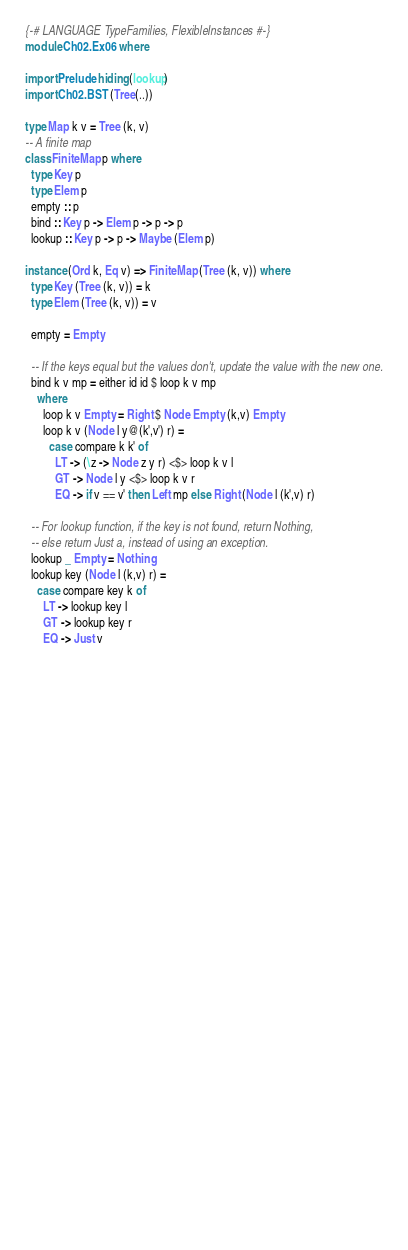<code> <loc_0><loc_0><loc_500><loc_500><_Haskell_>{-# LANGUAGE TypeFamilies, FlexibleInstances #-}
module Ch02.Ex06 where

import Prelude hiding (lookup)
import Ch02.BST (Tree(..))

type Map k v = Tree (k, v)
-- A finite map
class FiniteMap p where
  type Key p
  type Elem p
  empty :: p
  bind :: Key p -> Elem p -> p -> p
  lookup :: Key p -> p -> Maybe (Elem p)
  
instance (Ord k, Eq v) => FiniteMap (Tree (k, v)) where
  type Key (Tree (k, v)) = k
  type Elem (Tree (k, v)) = v
  
  empty = Empty
  
  -- If the keys equal but the values don't, update the value with the new one.
  bind k v mp = either id id $ loop k v mp 
    where
      loop k v Empty = Right $ Node Empty (k,v) Empty 
      loop k v (Node l y@(k',v') r) = 
        case compare k k' of
          LT -> (\z -> Node z y r) <$> loop k v l 
          GT -> Node l y <$> loop k v r
          EQ -> if v == v' then Left mp else Right (Node l (k',v) r)
  
  -- For lookup function, if the key is not found, return Nothing,
  -- else return Just a, instead of using an exception.
  lookup _ Empty = Nothing
  lookup key (Node l (k,v) r) = 
    case compare key k of 
      LT -> lookup key l 
      GT -> lookup key r
      EQ -> Just v



































      </code> 